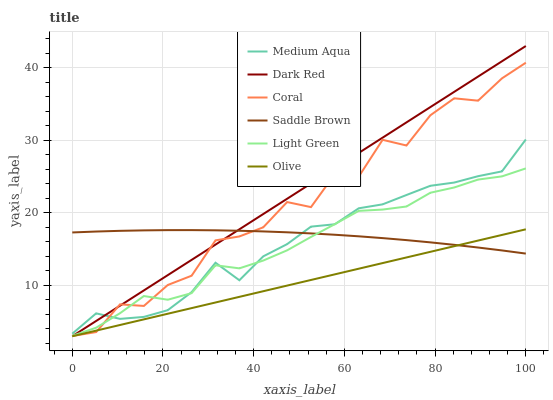Does Olive have the minimum area under the curve?
Answer yes or no. Yes. Does Dark Red have the maximum area under the curve?
Answer yes or no. Yes. Does Coral have the minimum area under the curve?
Answer yes or no. No. Does Coral have the maximum area under the curve?
Answer yes or no. No. Is Olive the smoothest?
Answer yes or no. Yes. Is Coral the roughest?
Answer yes or no. Yes. Is Medium Aqua the smoothest?
Answer yes or no. No. Is Medium Aqua the roughest?
Answer yes or no. No. Does Dark Red have the lowest value?
Answer yes or no. Yes. Does Coral have the lowest value?
Answer yes or no. No. Does Dark Red have the highest value?
Answer yes or no. Yes. Does Coral have the highest value?
Answer yes or no. No. Is Olive less than Medium Aqua?
Answer yes or no. Yes. Is Medium Aqua greater than Olive?
Answer yes or no. Yes. Does Saddle Brown intersect Olive?
Answer yes or no. Yes. Is Saddle Brown less than Olive?
Answer yes or no. No. Is Saddle Brown greater than Olive?
Answer yes or no. No. Does Olive intersect Medium Aqua?
Answer yes or no. No. 